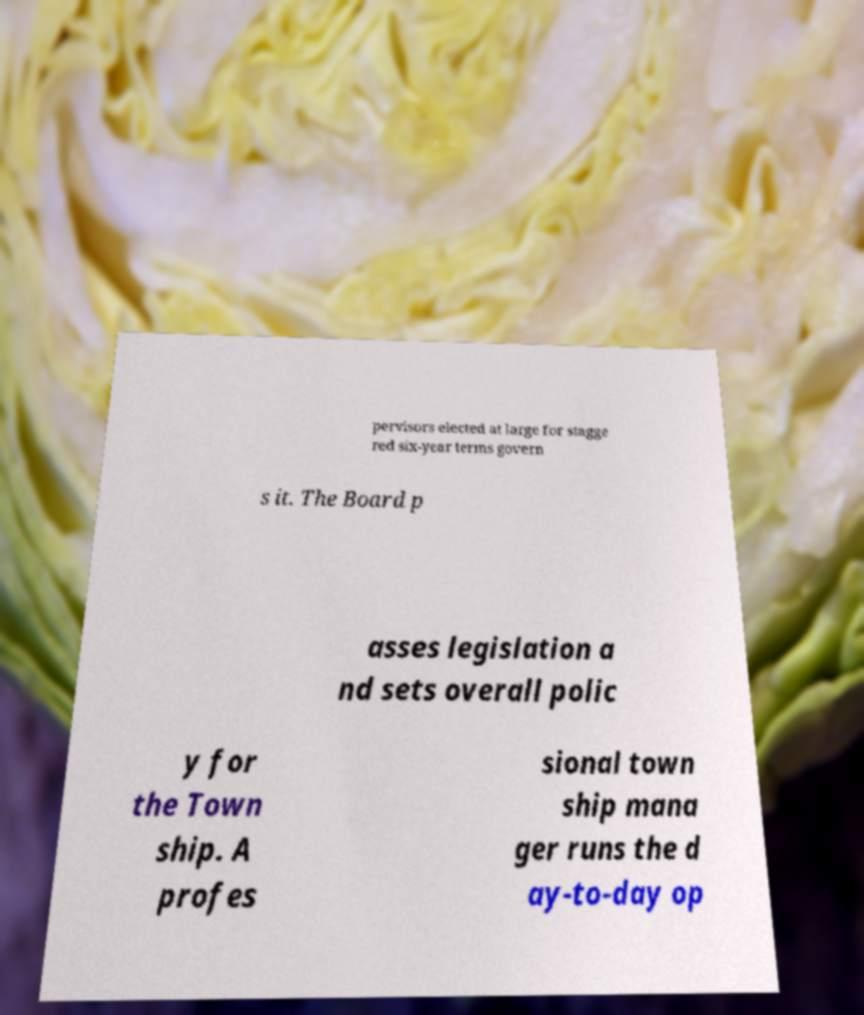Please identify and transcribe the text found in this image. pervisors elected at large for stagge red six-year terms govern s it. The Board p asses legislation a nd sets overall polic y for the Town ship. A profes sional town ship mana ger runs the d ay-to-day op 